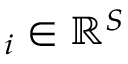Convert formula to latex. <formula><loc_0><loc_0><loc_500><loc_500>{ \chi } _ { i } \in { \mathbb { R } } ^ { S }</formula> 